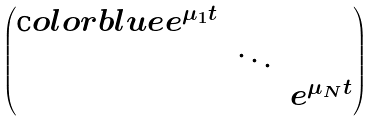<formula> <loc_0><loc_0><loc_500><loc_500>\begin{pmatrix} \text  color{blue} { e ^ { \mu _ { 1 } t } } & & \\ & \ddots & \\ & & e ^ { \mu _ { N } t } \end{pmatrix}</formula> 